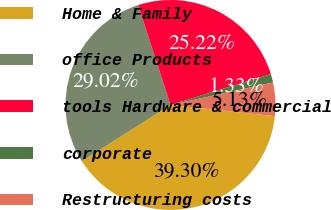Convert chart. <chart><loc_0><loc_0><loc_500><loc_500><pie_chart><fcel>Home & Family<fcel>office Products<fcel>tools Hardware & commercial<fcel>corporate<fcel>Restructuring costs<nl><fcel>39.3%<fcel>29.02%<fcel>25.22%<fcel>1.33%<fcel>5.13%<nl></chart> 